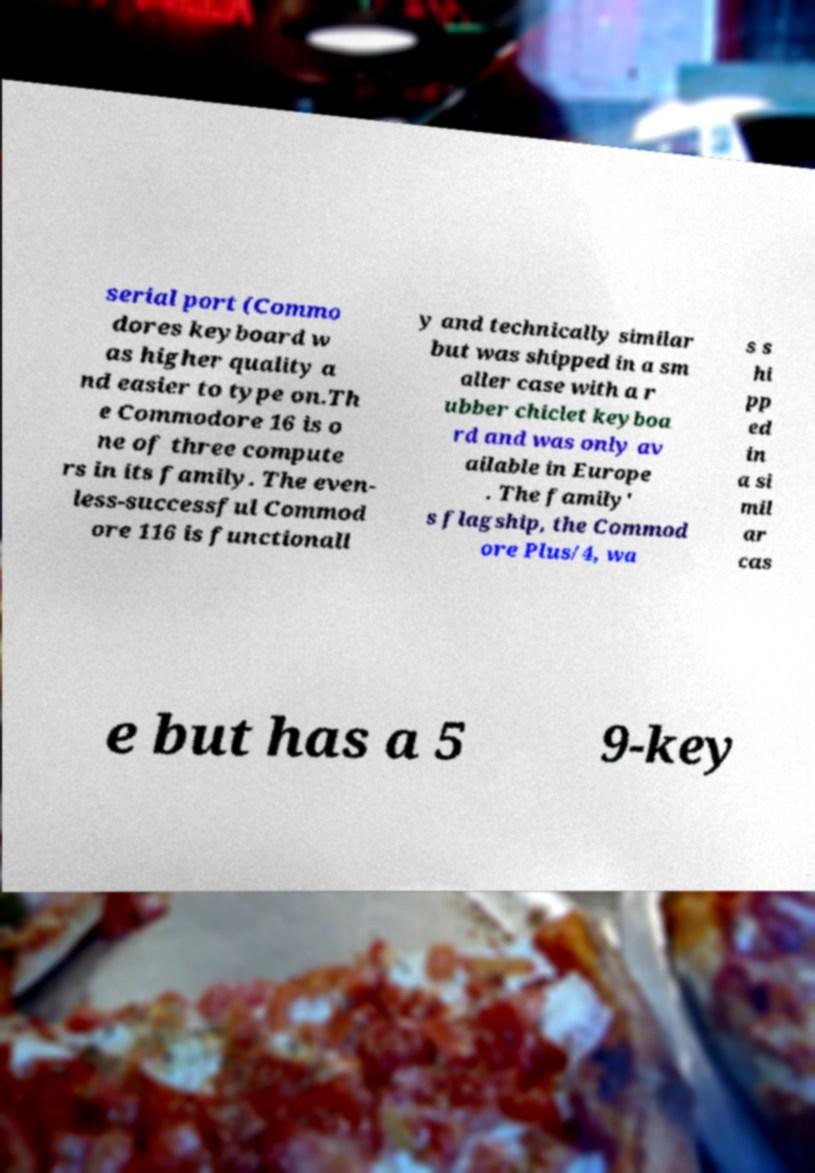I need the written content from this picture converted into text. Can you do that? serial port (Commo dores keyboard w as higher quality a nd easier to type on.Th e Commodore 16 is o ne of three compute rs in its family. The even- less-successful Commod ore 116 is functionall y and technically similar but was shipped in a sm aller case with a r ubber chiclet keyboa rd and was only av ailable in Europe . The family' s flagship, the Commod ore Plus/4, wa s s hi pp ed in a si mil ar cas e but has a 5 9-key 